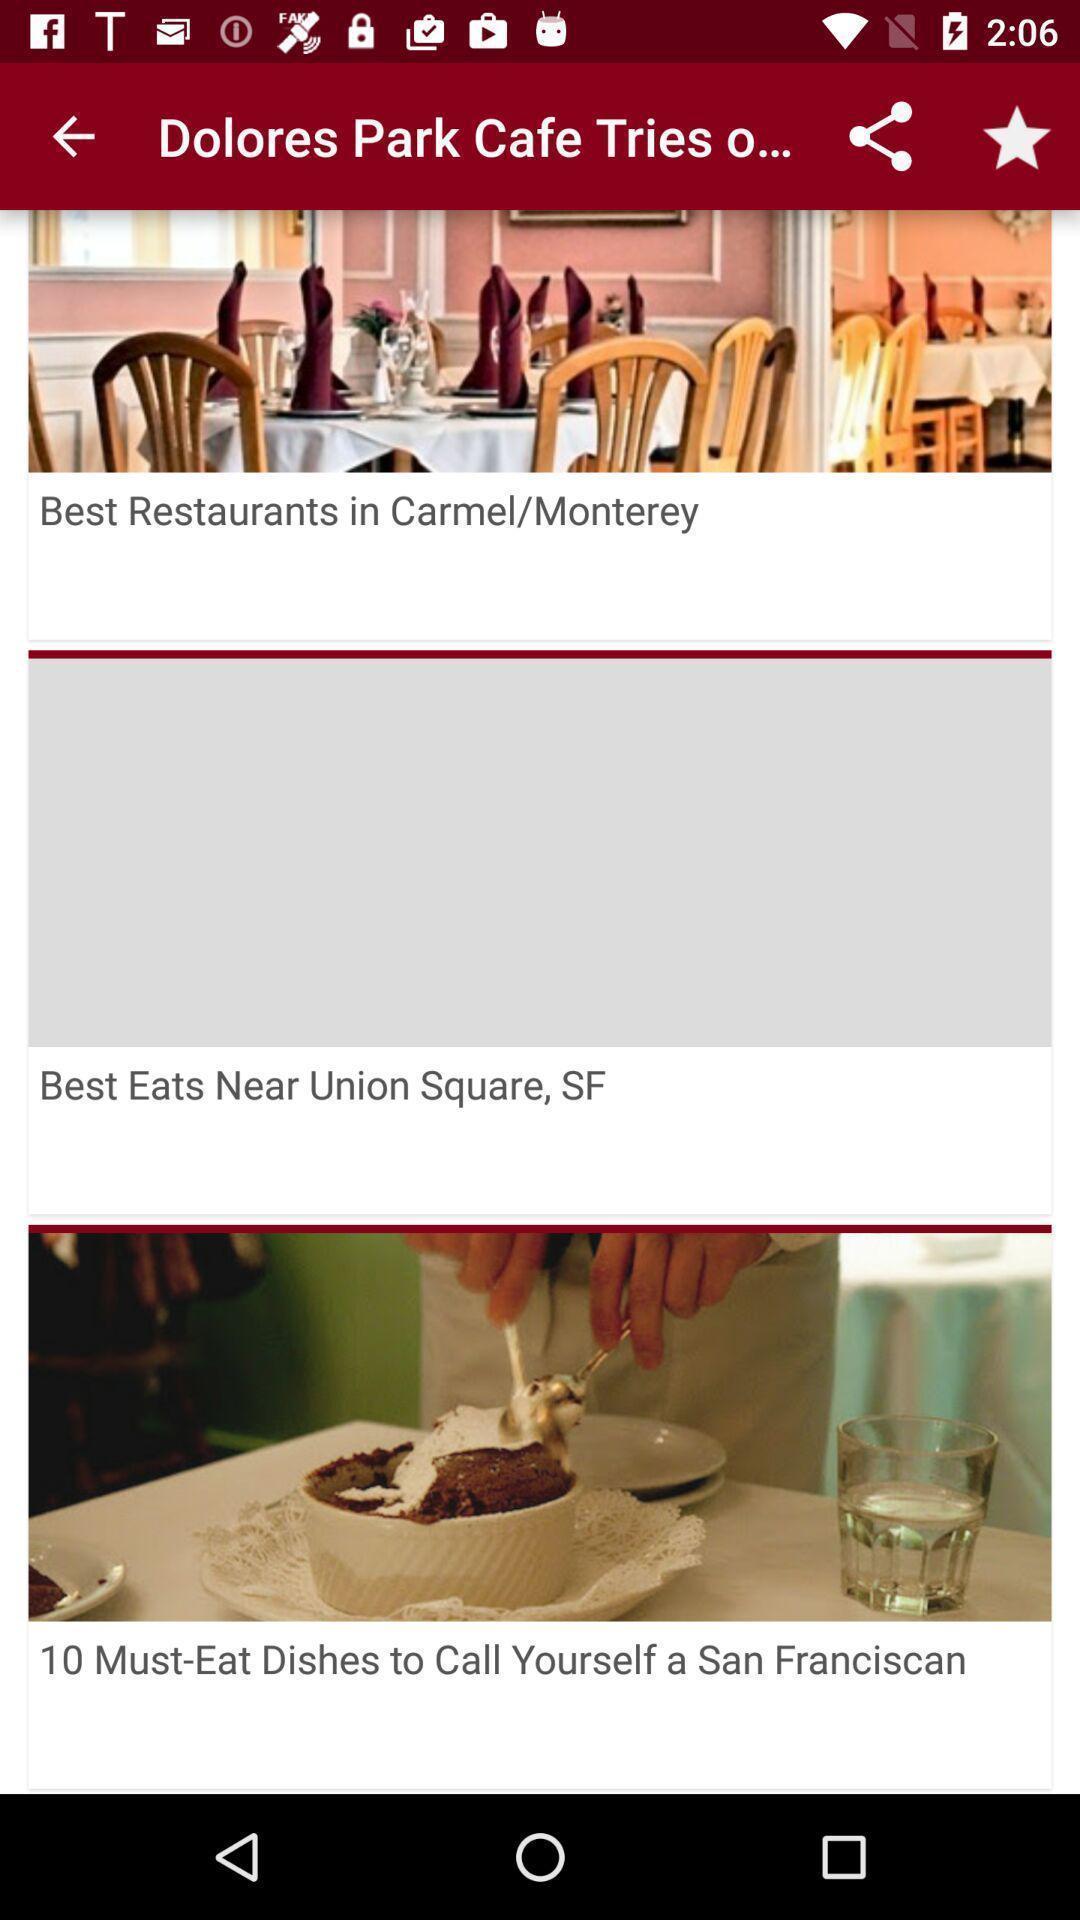Give me a summary of this screen capture. Various articles displayed of a eatery app. 